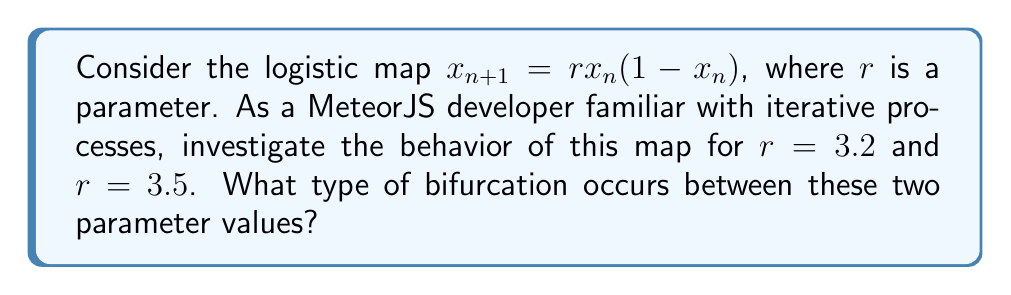Help me with this question. Let's approach this step-by-step:

1) First, let's recall that the logistic map is given by the equation:
   $$x_{n+1} = rx_n(1-x_n)$$

2) For $r = 3.2$:
   - Iterate the map for several initial conditions.
   - You'll observe that after some transient behavior, the system settles into a single fixed point.
   - This fixed point can be calculated by solving $x = rx(1-x)$:
     $$x = 3.2x(1-x)$$
     $$x = 3.2x - 3.2x^2$$
     $$3.2x^2 - 2.2x = 0$$
     $$x(3.2x - 2.2) = 0$$
     $$x = 0 \text{ or } x \approx 0.6875$$
   - The non-zero fixed point is stable.

3) For $r = 3.5$:
   - Iterate the map again for several initial conditions.
   - You'll notice that the system oscillates between two values.
   - These two values form a 2-cycle, meaning the system repeats every two iterations.

4) The transition from a single stable fixed point to a 2-cycle as $r$ increases is characteristic of a period-doubling bifurcation.

5) In the context of dynamical systems, this bifurcation occurs when the fixed point loses stability and gives birth to a stable 2-cycle.

6) The critical value where this occurs can be found by setting the derivative of the map at the fixed point equal to -1:
   $$\frac{d}{dx}(rx(1-x)) = r(1-2x) = -1$$
   
   Solving this equation along with the fixed point equation gives $r \approx 3.449$.

7) As a MeteorJS developer, you can think of this as a system transitioning from a stable state (single value) to an alternating state (toggling between two values) as you adjust a parameter, similar to how changing a configuration value might alter the behavior of your application.
Answer: Period-doubling bifurcation 